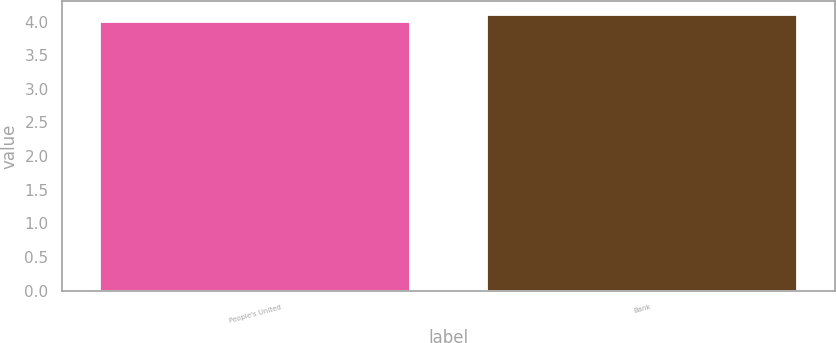Convert chart. <chart><loc_0><loc_0><loc_500><loc_500><bar_chart><fcel>People's United<fcel>Bank<nl><fcel>4<fcel>4.1<nl></chart> 